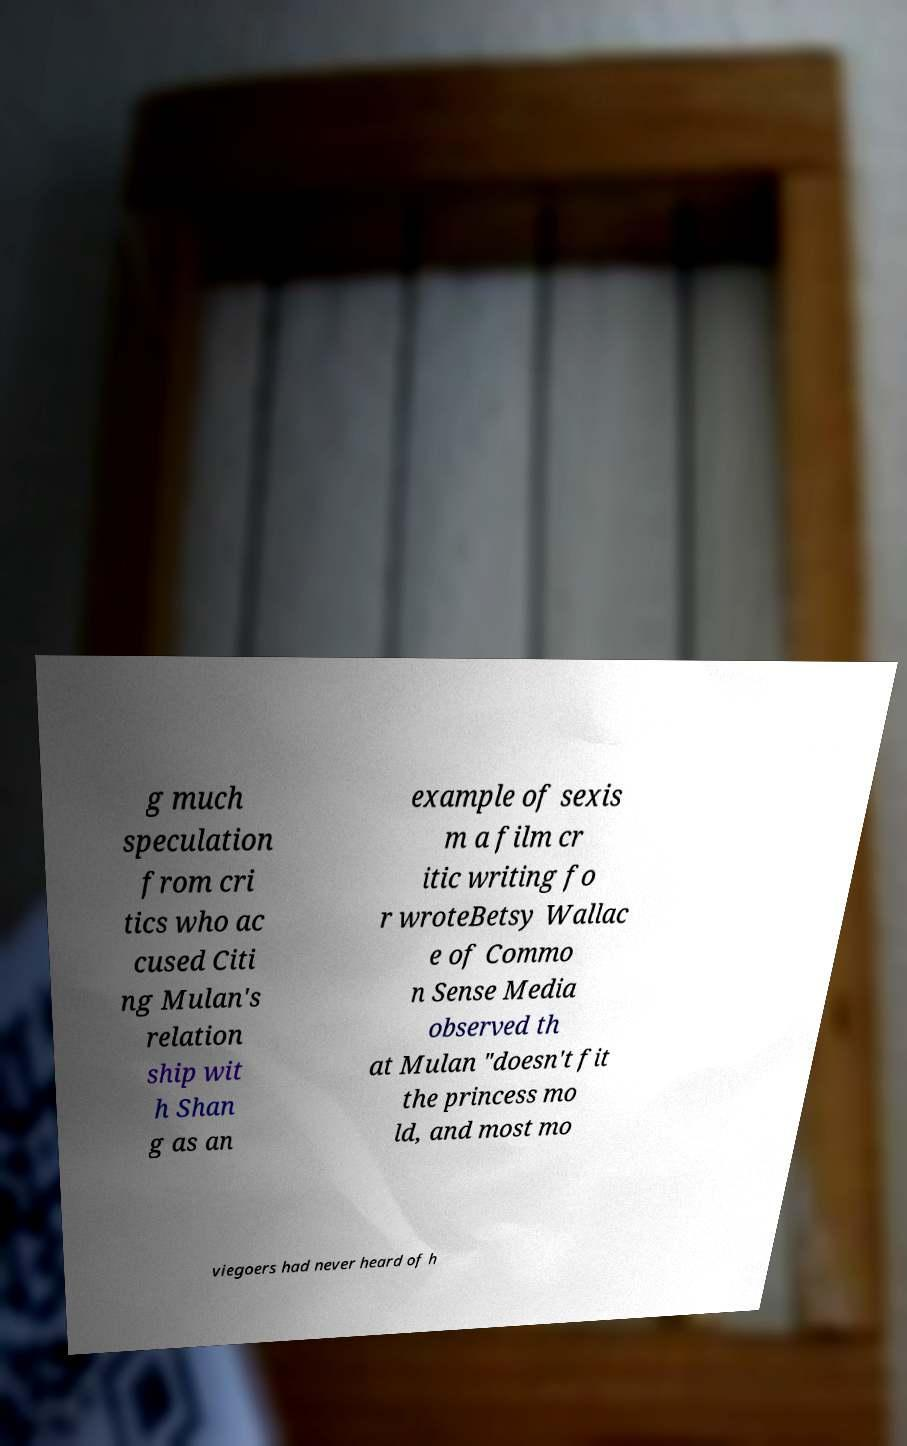Could you extract and type out the text from this image? g much speculation from cri tics who ac cused Citi ng Mulan's relation ship wit h Shan g as an example of sexis m a film cr itic writing fo r wroteBetsy Wallac e of Commo n Sense Media observed th at Mulan "doesn't fit the princess mo ld, and most mo viegoers had never heard of h 